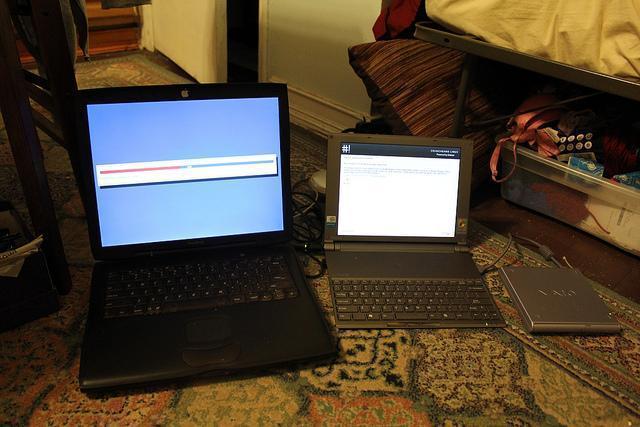How many computers?
Give a very brief answer. 2. How many laptops are in the picture?
Give a very brief answer. 3. How many keyboards are there?
Give a very brief answer. 2. How many bananas are there?
Give a very brief answer. 0. 